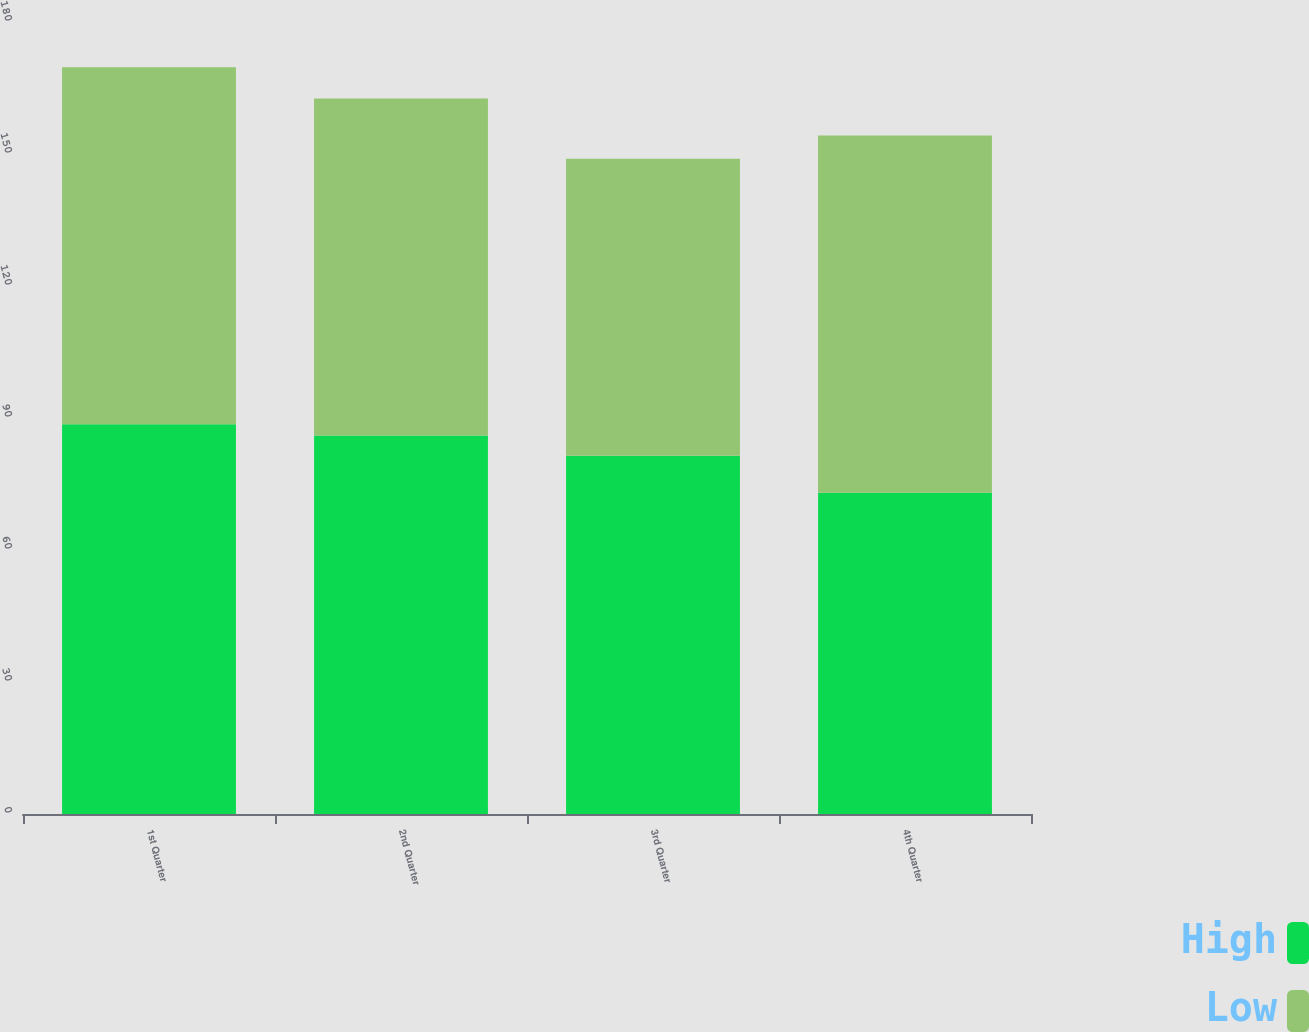Convert chart to OTSL. <chart><loc_0><loc_0><loc_500><loc_500><stacked_bar_chart><ecel><fcel>1st Quarter<fcel>2nd Quarter<fcel>3rd Quarter<fcel>4th Quarter<nl><fcel>High<fcel>88.56<fcel>86<fcel>81.43<fcel>73<nl><fcel>Low<fcel>81.18<fcel>76.59<fcel>67.51<fcel>81.18<nl></chart> 